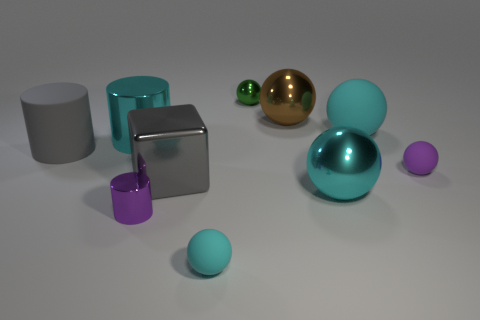How many cyan spheres must be subtracted to get 1 cyan spheres? 2 Subtract all purple cylinders. How many cyan balls are left? 3 Subtract 1 balls. How many balls are left? 5 Subtract all tiny green balls. How many balls are left? 5 Subtract all green balls. How many balls are left? 5 Subtract all gray spheres. Subtract all gray blocks. How many spheres are left? 6 Subtract all cylinders. How many objects are left? 7 Add 2 small green objects. How many small green objects are left? 3 Add 2 tiny purple shiny cylinders. How many tiny purple shiny cylinders exist? 3 Subtract 0 cyan cubes. How many objects are left? 10 